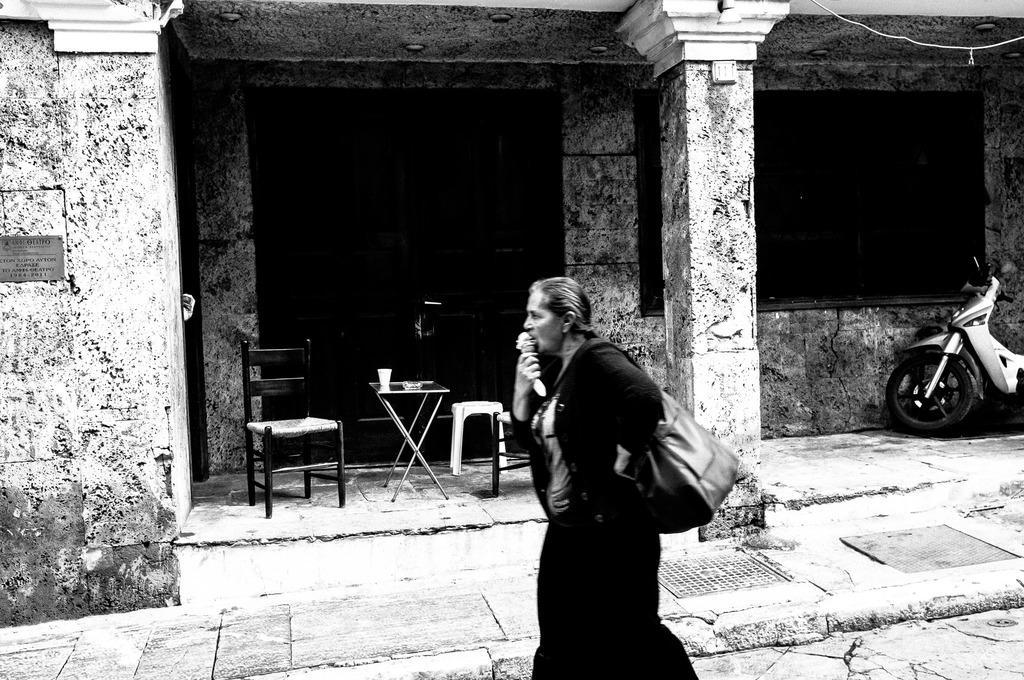Describe this image in one or two sentences. In this picture there is a woman carrying a handbag and eating an ice cream. In the background there is a table and chair. 